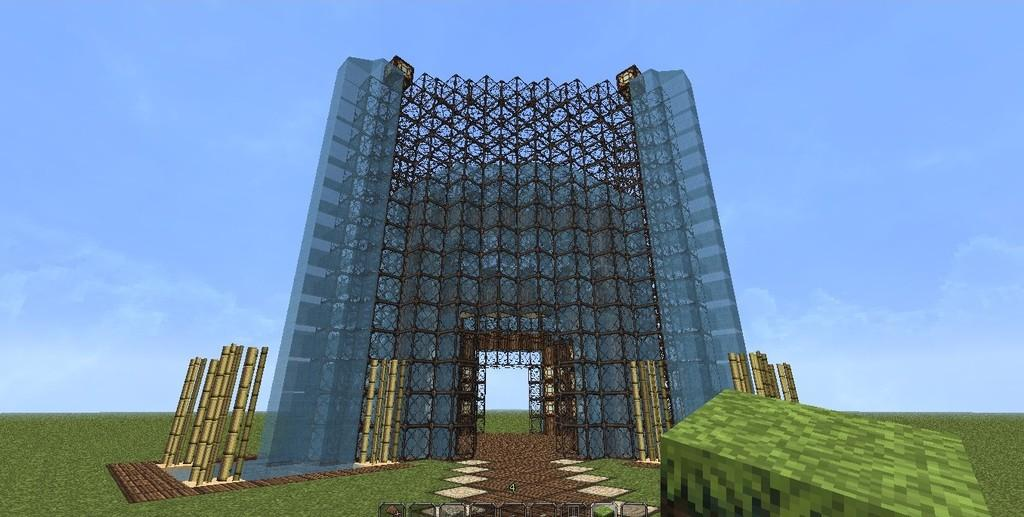What type of image is shown in the picture? The image is a graphics image. What can be seen in the foreground of the image? There is a building structure in the image. What color is the background of the image? The background of the image is blue. What type of knife is being used to cut the chair in the image? There is no knife or chair present in the image; it only features a building structure and a blue background. 